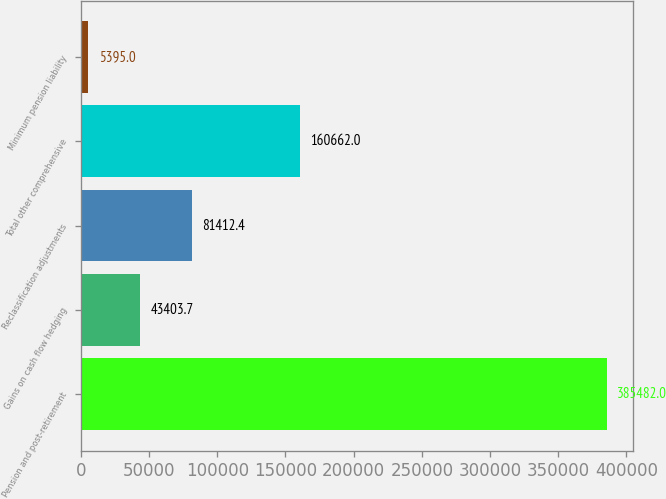Convert chart to OTSL. <chart><loc_0><loc_0><loc_500><loc_500><bar_chart><fcel>Pension and post-retirement<fcel>Gains on cash flow hedging<fcel>Reclassification adjustments<fcel>Total other comprehensive<fcel>Minimum pension liability<nl><fcel>385482<fcel>43403.7<fcel>81412.4<fcel>160662<fcel>5395<nl></chart> 